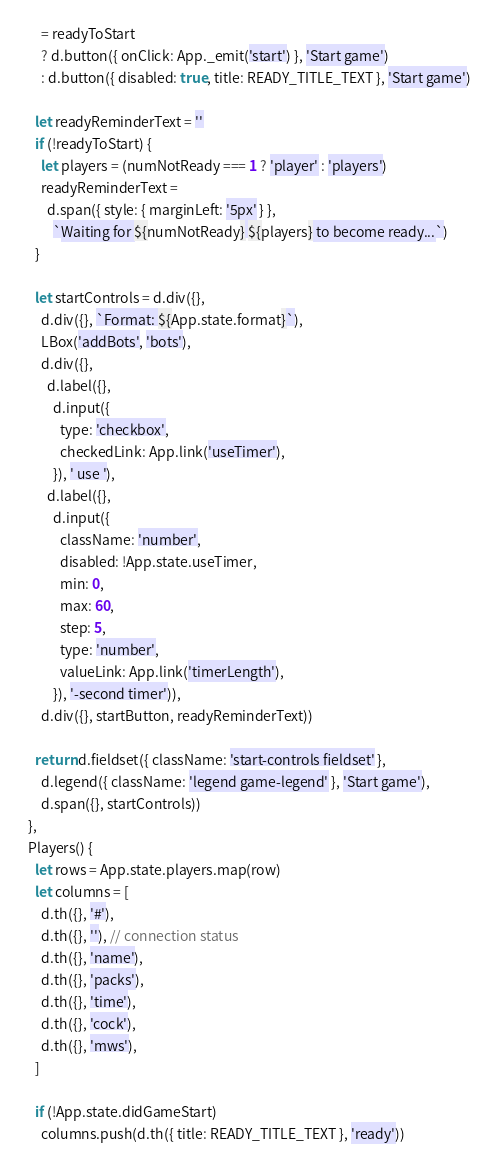<code> <loc_0><loc_0><loc_500><loc_500><_JavaScript_>      = readyToStart
      ? d.button({ onClick: App._emit('start') }, 'Start game')
      : d.button({ disabled: true, title: READY_TITLE_TEXT }, 'Start game')

    let readyReminderText = ''
    if (!readyToStart) {
      let players = (numNotReady === 1 ? 'player' : 'players')
      readyReminderText =
        d.span({ style: { marginLeft: '5px' } },
          `Waiting for ${numNotReady} ${players} to become ready...`)
    }

    let startControls = d.div({},
      d.div({}, `Format: ${App.state.format}`),
      LBox('addBots', 'bots'),
      d.div({},
        d.label({},
          d.input({
            type: 'checkbox',
            checkedLink: App.link('useTimer'),
          }), ' use '),
        d.label({},
          d.input({
            className: 'number',
            disabled: !App.state.useTimer,
            min: 0,
            max: 60,
            step: 5,
            type: 'number',
            valueLink: App.link('timerLength'),
          }), '-second timer')),
      d.div({}, startButton, readyReminderText))

    return d.fieldset({ className: 'start-controls fieldset' },
      d.legend({ className: 'legend game-legend' }, 'Start game'),
      d.span({}, startControls))
  },
  Players() {
    let rows = App.state.players.map(row)
    let columns = [
      d.th({}, '#'),
      d.th({}, ''), // connection status
      d.th({}, 'name'),
      d.th({}, 'packs'),
      d.th({}, 'time'),
      d.th({}, 'cock'),
      d.th({}, 'mws'),
    ]

    if (!App.state.didGameStart)
      columns.push(d.th({ title: READY_TITLE_TEXT }, 'ready'))
</code> 